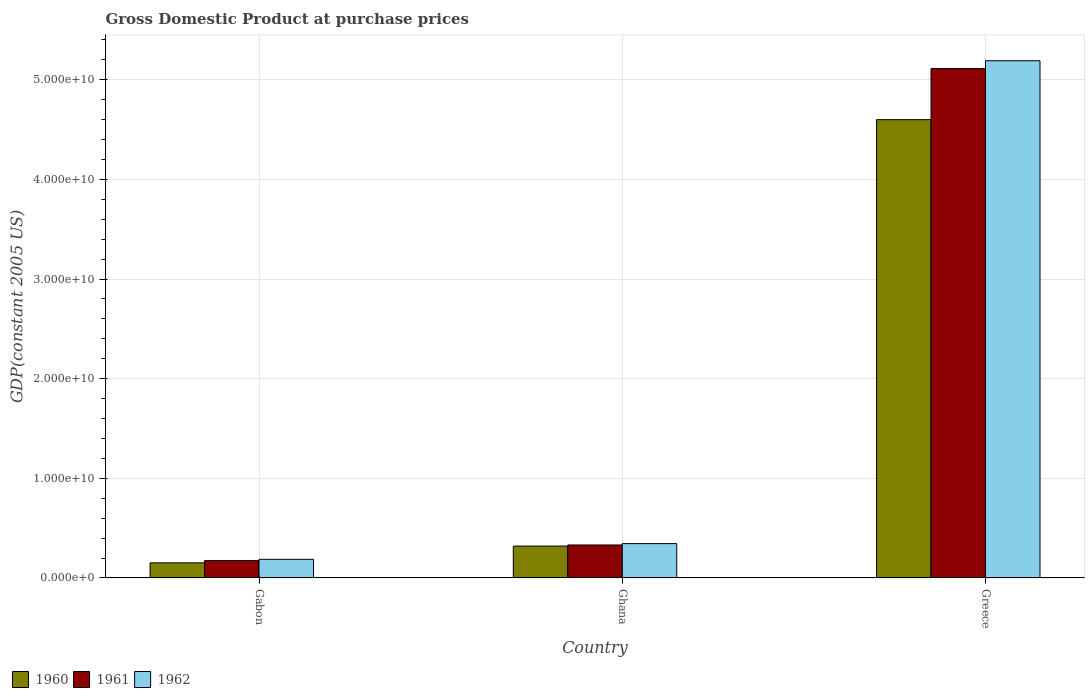How many groups of bars are there?
Your answer should be very brief. 3. Are the number of bars per tick equal to the number of legend labels?
Keep it short and to the point. Yes. What is the label of the 3rd group of bars from the left?
Make the answer very short. Greece. In how many cases, is the number of bars for a given country not equal to the number of legend labels?
Offer a terse response. 0. What is the GDP at purchase prices in 1962 in Greece?
Make the answer very short. 5.19e+1. Across all countries, what is the maximum GDP at purchase prices in 1962?
Keep it short and to the point. 5.19e+1. Across all countries, what is the minimum GDP at purchase prices in 1960?
Offer a very short reply. 1.52e+09. In which country was the GDP at purchase prices in 1961 minimum?
Your answer should be very brief. Gabon. What is the total GDP at purchase prices in 1961 in the graph?
Provide a succinct answer. 5.62e+1. What is the difference between the GDP at purchase prices in 1960 in Gabon and that in Ghana?
Ensure brevity in your answer.  -1.68e+09. What is the difference between the GDP at purchase prices in 1960 in Ghana and the GDP at purchase prices in 1961 in Greece?
Keep it short and to the point. -4.79e+1. What is the average GDP at purchase prices in 1960 per country?
Your answer should be very brief. 1.69e+1. What is the difference between the GDP at purchase prices of/in 1960 and GDP at purchase prices of/in 1962 in Greece?
Your answer should be compact. -5.91e+09. What is the ratio of the GDP at purchase prices in 1960 in Ghana to that in Greece?
Ensure brevity in your answer.  0.07. What is the difference between the highest and the second highest GDP at purchase prices in 1961?
Ensure brevity in your answer.  4.94e+1. What is the difference between the highest and the lowest GDP at purchase prices in 1962?
Your answer should be compact. 5.00e+1. How many bars are there?
Offer a terse response. 9. Are all the bars in the graph horizontal?
Your response must be concise. No. Does the graph contain any zero values?
Your response must be concise. No. Does the graph contain grids?
Provide a short and direct response. Yes. What is the title of the graph?
Keep it short and to the point. Gross Domestic Product at purchase prices. Does "2015" appear as one of the legend labels in the graph?
Your answer should be very brief. No. What is the label or title of the X-axis?
Your answer should be compact. Country. What is the label or title of the Y-axis?
Provide a succinct answer. GDP(constant 2005 US). What is the GDP(constant 2005 US) in 1960 in Gabon?
Keep it short and to the point. 1.52e+09. What is the GDP(constant 2005 US) of 1961 in Gabon?
Give a very brief answer. 1.74e+09. What is the GDP(constant 2005 US) of 1962 in Gabon?
Keep it short and to the point. 1.87e+09. What is the GDP(constant 2005 US) of 1960 in Ghana?
Provide a succinct answer. 3.20e+09. What is the GDP(constant 2005 US) in 1961 in Ghana?
Make the answer very short. 3.31e+09. What is the GDP(constant 2005 US) of 1962 in Ghana?
Provide a short and direct response. 3.45e+09. What is the GDP(constant 2005 US) of 1960 in Greece?
Give a very brief answer. 4.60e+1. What is the GDP(constant 2005 US) of 1961 in Greece?
Offer a terse response. 5.11e+1. What is the GDP(constant 2005 US) of 1962 in Greece?
Your answer should be compact. 5.19e+1. Across all countries, what is the maximum GDP(constant 2005 US) of 1960?
Your response must be concise. 4.60e+1. Across all countries, what is the maximum GDP(constant 2005 US) in 1961?
Provide a succinct answer. 5.11e+1. Across all countries, what is the maximum GDP(constant 2005 US) in 1962?
Your answer should be compact. 5.19e+1. Across all countries, what is the minimum GDP(constant 2005 US) of 1960?
Offer a terse response. 1.52e+09. Across all countries, what is the minimum GDP(constant 2005 US) in 1961?
Offer a terse response. 1.74e+09. Across all countries, what is the minimum GDP(constant 2005 US) of 1962?
Ensure brevity in your answer.  1.87e+09. What is the total GDP(constant 2005 US) of 1960 in the graph?
Your response must be concise. 5.07e+1. What is the total GDP(constant 2005 US) in 1961 in the graph?
Ensure brevity in your answer.  5.62e+1. What is the total GDP(constant 2005 US) of 1962 in the graph?
Provide a succinct answer. 5.72e+1. What is the difference between the GDP(constant 2005 US) of 1960 in Gabon and that in Ghana?
Your answer should be very brief. -1.68e+09. What is the difference between the GDP(constant 2005 US) of 1961 in Gabon and that in Ghana?
Provide a short and direct response. -1.57e+09. What is the difference between the GDP(constant 2005 US) in 1962 in Gabon and that in Ghana?
Make the answer very short. -1.58e+09. What is the difference between the GDP(constant 2005 US) of 1960 in Gabon and that in Greece?
Your answer should be very brief. -4.45e+1. What is the difference between the GDP(constant 2005 US) in 1961 in Gabon and that in Greece?
Ensure brevity in your answer.  -4.94e+1. What is the difference between the GDP(constant 2005 US) in 1962 in Gabon and that in Greece?
Keep it short and to the point. -5.00e+1. What is the difference between the GDP(constant 2005 US) in 1960 in Ghana and that in Greece?
Offer a terse response. -4.28e+1. What is the difference between the GDP(constant 2005 US) in 1961 in Ghana and that in Greece?
Offer a very short reply. -4.78e+1. What is the difference between the GDP(constant 2005 US) of 1962 in Ghana and that in Greece?
Ensure brevity in your answer.  -4.85e+1. What is the difference between the GDP(constant 2005 US) in 1960 in Gabon and the GDP(constant 2005 US) in 1961 in Ghana?
Ensure brevity in your answer.  -1.79e+09. What is the difference between the GDP(constant 2005 US) in 1960 in Gabon and the GDP(constant 2005 US) in 1962 in Ghana?
Keep it short and to the point. -1.93e+09. What is the difference between the GDP(constant 2005 US) in 1961 in Gabon and the GDP(constant 2005 US) in 1962 in Ghana?
Keep it short and to the point. -1.71e+09. What is the difference between the GDP(constant 2005 US) of 1960 in Gabon and the GDP(constant 2005 US) of 1961 in Greece?
Provide a succinct answer. -4.96e+1. What is the difference between the GDP(constant 2005 US) of 1960 in Gabon and the GDP(constant 2005 US) of 1962 in Greece?
Your response must be concise. -5.04e+1. What is the difference between the GDP(constant 2005 US) of 1961 in Gabon and the GDP(constant 2005 US) of 1962 in Greece?
Offer a terse response. -5.02e+1. What is the difference between the GDP(constant 2005 US) of 1960 in Ghana and the GDP(constant 2005 US) of 1961 in Greece?
Provide a short and direct response. -4.79e+1. What is the difference between the GDP(constant 2005 US) of 1960 in Ghana and the GDP(constant 2005 US) of 1962 in Greece?
Your answer should be very brief. -4.87e+1. What is the difference between the GDP(constant 2005 US) in 1961 in Ghana and the GDP(constant 2005 US) in 1962 in Greece?
Give a very brief answer. -4.86e+1. What is the average GDP(constant 2005 US) of 1960 per country?
Your answer should be very brief. 1.69e+1. What is the average GDP(constant 2005 US) of 1961 per country?
Give a very brief answer. 1.87e+1. What is the average GDP(constant 2005 US) in 1962 per country?
Make the answer very short. 1.91e+1. What is the difference between the GDP(constant 2005 US) in 1960 and GDP(constant 2005 US) in 1961 in Gabon?
Offer a terse response. -2.24e+08. What is the difference between the GDP(constant 2005 US) in 1960 and GDP(constant 2005 US) in 1962 in Gabon?
Offer a very short reply. -3.54e+08. What is the difference between the GDP(constant 2005 US) in 1961 and GDP(constant 2005 US) in 1962 in Gabon?
Your response must be concise. -1.30e+08. What is the difference between the GDP(constant 2005 US) in 1960 and GDP(constant 2005 US) in 1961 in Ghana?
Keep it short and to the point. -1.10e+08. What is the difference between the GDP(constant 2005 US) of 1960 and GDP(constant 2005 US) of 1962 in Ghana?
Ensure brevity in your answer.  -2.46e+08. What is the difference between the GDP(constant 2005 US) of 1961 and GDP(constant 2005 US) of 1962 in Ghana?
Your answer should be compact. -1.36e+08. What is the difference between the GDP(constant 2005 US) in 1960 and GDP(constant 2005 US) in 1961 in Greece?
Make the answer very short. -5.13e+09. What is the difference between the GDP(constant 2005 US) of 1960 and GDP(constant 2005 US) of 1962 in Greece?
Provide a short and direct response. -5.91e+09. What is the difference between the GDP(constant 2005 US) of 1961 and GDP(constant 2005 US) of 1962 in Greece?
Ensure brevity in your answer.  -7.84e+08. What is the ratio of the GDP(constant 2005 US) in 1960 in Gabon to that in Ghana?
Ensure brevity in your answer.  0.47. What is the ratio of the GDP(constant 2005 US) in 1961 in Gabon to that in Ghana?
Offer a very short reply. 0.53. What is the ratio of the GDP(constant 2005 US) of 1962 in Gabon to that in Ghana?
Offer a terse response. 0.54. What is the ratio of the GDP(constant 2005 US) in 1960 in Gabon to that in Greece?
Make the answer very short. 0.03. What is the ratio of the GDP(constant 2005 US) of 1961 in Gabon to that in Greece?
Offer a very short reply. 0.03. What is the ratio of the GDP(constant 2005 US) of 1962 in Gabon to that in Greece?
Ensure brevity in your answer.  0.04. What is the ratio of the GDP(constant 2005 US) in 1960 in Ghana to that in Greece?
Provide a succinct answer. 0.07. What is the ratio of the GDP(constant 2005 US) of 1961 in Ghana to that in Greece?
Keep it short and to the point. 0.06. What is the ratio of the GDP(constant 2005 US) in 1962 in Ghana to that in Greece?
Offer a terse response. 0.07. What is the difference between the highest and the second highest GDP(constant 2005 US) in 1960?
Ensure brevity in your answer.  4.28e+1. What is the difference between the highest and the second highest GDP(constant 2005 US) of 1961?
Provide a succinct answer. 4.78e+1. What is the difference between the highest and the second highest GDP(constant 2005 US) in 1962?
Provide a short and direct response. 4.85e+1. What is the difference between the highest and the lowest GDP(constant 2005 US) in 1960?
Your answer should be very brief. 4.45e+1. What is the difference between the highest and the lowest GDP(constant 2005 US) of 1961?
Your response must be concise. 4.94e+1. What is the difference between the highest and the lowest GDP(constant 2005 US) in 1962?
Provide a succinct answer. 5.00e+1. 